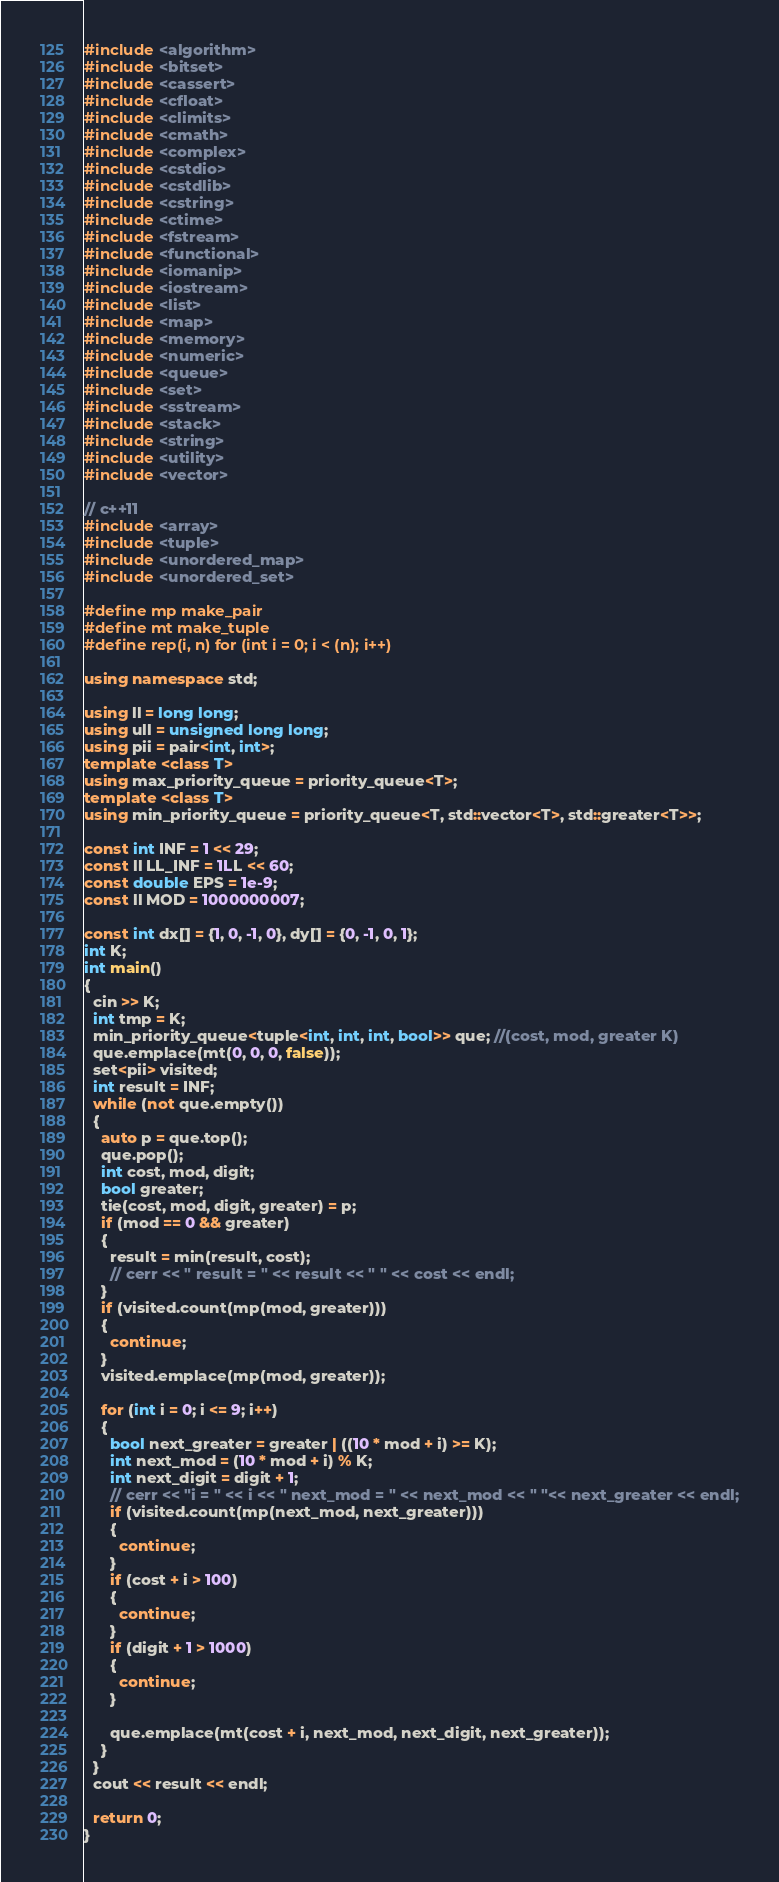<code> <loc_0><loc_0><loc_500><loc_500><_C++_>#include <algorithm>
#include <bitset>
#include <cassert>
#include <cfloat>
#include <climits>
#include <cmath>
#include <complex>
#include <cstdio>
#include <cstdlib>
#include <cstring>
#include <ctime>
#include <fstream>
#include <functional>
#include <iomanip>
#include <iostream>
#include <list>
#include <map>
#include <memory>
#include <numeric>
#include <queue>
#include <set>
#include <sstream>
#include <stack>
#include <string>
#include <utility>
#include <vector>

// c++11
#include <array>
#include <tuple>
#include <unordered_map>
#include <unordered_set>

#define mp make_pair
#define mt make_tuple
#define rep(i, n) for (int i = 0; i < (n); i++)

using namespace std;

using ll = long long;
using ull = unsigned long long;
using pii = pair<int, int>;
template <class T>
using max_priority_queue = priority_queue<T>;
template <class T>
using min_priority_queue = priority_queue<T, std::vector<T>, std::greater<T>>;

const int INF = 1 << 29;
const ll LL_INF = 1LL << 60;
const double EPS = 1e-9;
const ll MOD = 1000000007;

const int dx[] = {1, 0, -1, 0}, dy[] = {0, -1, 0, 1};
int K;
int main()
{
  cin >> K;
  int tmp = K;
  min_priority_queue<tuple<int, int, int, bool>> que; //(cost, mod, greater K)
  que.emplace(mt(0, 0, 0, false));
  set<pii> visited;
  int result = INF;
  while (not que.empty())
  {
    auto p = que.top();
    que.pop();
    int cost, mod, digit;
    bool greater;
    tie(cost, mod, digit, greater) = p;
    if (mod == 0 && greater)
    {
      result = min(result, cost);
      // cerr << " result = " << result << " " << cost << endl;
    }
    if (visited.count(mp(mod, greater)))
    {
      continue;
    }
    visited.emplace(mp(mod, greater));

    for (int i = 0; i <= 9; i++)
    {
      bool next_greater = greater | ((10 * mod + i) >= K);
      int next_mod = (10 * mod + i) % K;
      int next_digit = digit + 1;
      // cerr << "i = " << i << " next_mod = " << next_mod << " "<< next_greater << endl;
      if (visited.count(mp(next_mod, next_greater)))
      {
        continue;
      }
      if (cost + i > 100)
      {
        continue;
      }
      if (digit + 1 > 1000)
      {
        continue;
      }

      que.emplace(mt(cost + i, next_mod, next_digit, next_greater));
    }
  }
  cout << result << endl;

  return 0;
}
</code> 